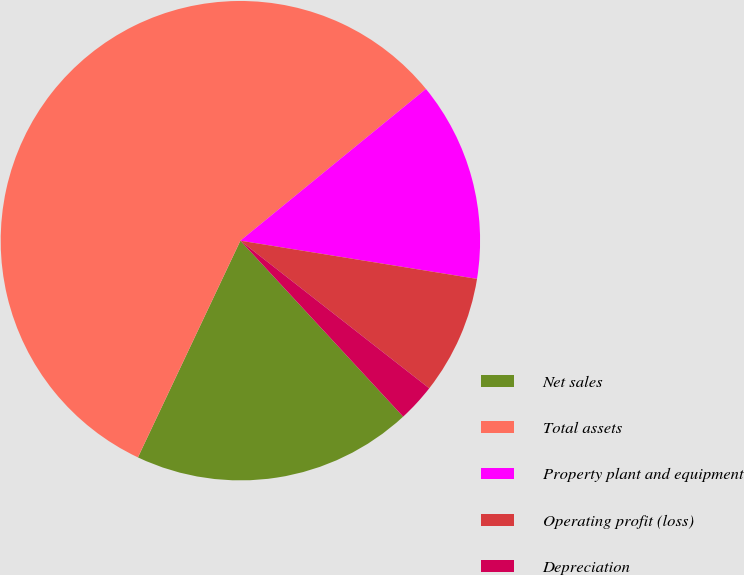Convert chart. <chart><loc_0><loc_0><loc_500><loc_500><pie_chart><fcel>Net sales<fcel>Total assets<fcel>Property plant and equipment<fcel>Operating profit (loss)<fcel>Depreciation<nl><fcel>18.91%<fcel>57.06%<fcel>13.46%<fcel>8.01%<fcel>2.56%<nl></chart> 